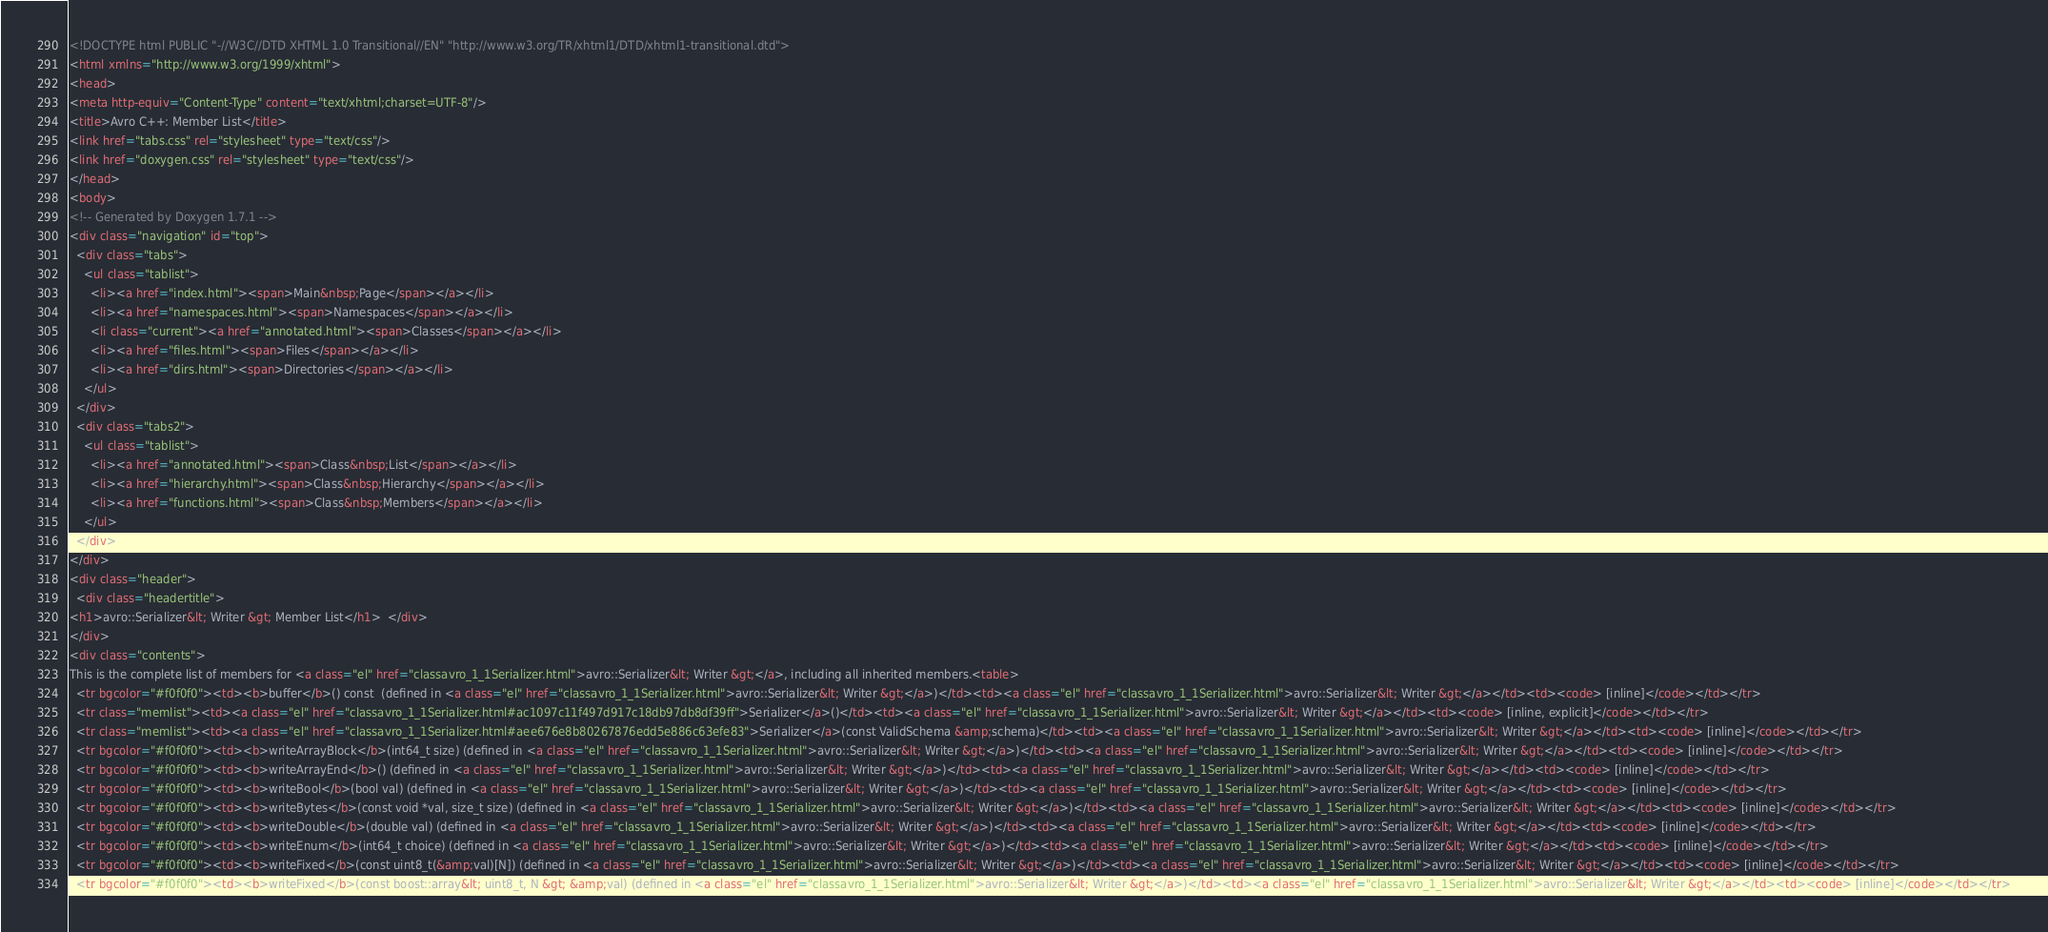Convert code to text. <code><loc_0><loc_0><loc_500><loc_500><_HTML_><!DOCTYPE html PUBLIC "-//W3C//DTD XHTML 1.0 Transitional//EN" "http://www.w3.org/TR/xhtml1/DTD/xhtml1-transitional.dtd">
<html xmlns="http://www.w3.org/1999/xhtml">
<head>
<meta http-equiv="Content-Type" content="text/xhtml;charset=UTF-8"/>
<title>Avro C++: Member List</title>
<link href="tabs.css" rel="stylesheet" type="text/css"/>
<link href="doxygen.css" rel="stylesheet" type="text/css"/>
</head>
<body>
<!-- Generated by Doxygen 1.7.1 -->
<div class="navigation" id="top">
  <div class="tabs">
    <ul class="tablist">
      <li><a href="index.html"><span>Main&nbsp;Page</span></a></li>
      <li><a href="namespaces.html"><span>Namespaces</span></a></li>
      <li class="current"><a href="annotated.html"><span>Classes</span></a></li>
      <li><a href="files.html"><span>Files</span></a></li>
      <li><a href="dirs.html"><span>Directories</span></a></li>
    </ul>
  </div>
  <div class="tabs2">
    <ul class="tablist">
      <li><a href="annotated.html"><span>Class&nbsp;List</span></a></li>
      <li><a href="hierarchy.html"><span>Class&nbsp;Hierarchy</span></a></li>
      <li><a href="functions.html"><span>Class&nbsp;Members</span></a></li>
    </ul>
  </div>
</div>
<div class="header">
  <div class="headertitle">
<h1>avro::Serializer&lt; Writer &gt; Member List</h1>  </div>
</div>
<div class="contents">
This is the complete list of members for <a class="el" href="classavro_1_1Serializer.html">avro::Serializer&lt; Writer &gt;</a>, including all inherited members.<table>
  <tr bgcolor="#f0f0f0"><td><b>buffer</b>() const  (defined in <a class="el" href="classavro_1_1Serializer.html">avro::Serializer&lt; Writer &gt;</a>)</td><td><a class="el" href="classavro_1_1Serializer.html">avro::Serializer&lt; Writer &gt;</a></td><td><code> [inline]</code></td></tr>
  <tr class="memlist"><td><a class="el" href="classavro_1_1Serializer.html#ac1097c11f497d917c18db97db8df39ff">Serializer</a>()</td><td><a class="el" href="classavro_1_1Serializer.html">avro::Serializer&lt; Writer &gt;</a></td><td><code> [inline, explicit]</code></td></tr>
  <tr class="memlist"><td><a class="el" href="classavro_1_1Serializer.html#aee676e8b80267876edd5e886c63efe83">Serializer</a>(const ValidSchema &amp;schema)</td><td><a class="el" href="classavro_1_1Serializer.html">avro::Serializer&lt; Writer &gt;</a></td><td><code> [inline]</code></td></tr>
  <tr bgcolor="#f0f0f0"><td><b>writeArrayBlock</b>(int64_t size) (defined in <a class="el" href="classavro_1_1Serializer.html">avro::Serializer&lt; Writer &gt;</a>)</td><td><a class="el" href="classavro_1_1Serializer.html">avro::Serializer&lt; Writer &gt;</a></td><td><code> [inline]</code></td></tr>
  <tr bgcolor="#f0f0f0"><td><b>writeArrayEnd</b>() (defined in <a class="el" href="classavro_1_1Serializer.html">avro::Serializer&lt; Writer &gt;</a>)</td><td><a class="el" href="classavro_1_1Serializer.html">avro::Serializer&lt; Writer &gt;</a></td><td><code> [inline]</code></td></tr>
  <tr bgcolor="#f0f0f0"><td><b>writeBool</b>(bool val) (defined in <a class="el" href="classavro_1_1Serializer.html">avro::Serializer&lt; Writer &gt;</a>)</td><td><a class="el" href="classavro_1_1Serializer.html">avro::Serializer&lt; Writer &gt;</a></td><td><code> [inline]</code></td></tr>
  <tr bgcolor="#f0f0f0"><td><b>writeBytes</b>(const void *val, size_t size) (defined in <a class="el" href="classavro_1_1Serializer.html">avro::Serializer&lt; Writer &gt;</a>)</td><td><a class="el" href="classavro_1_1Serializer.html">avro::Serializer&lt; Writer &gt;</a></td><td><code> [inline]</code></td></tr>
  <tr bgcolor="#f0f0f0"><td><b>writeDouble</b>(double val) (defined in <a class="el" href="classavro_1_1Serializer.html">avro::Serializer&lt; Writer &gt;</a>)</td><td><a class="el" href="classavro_1_1Serializer.html">avro::Serializer&lt; Writer &gt;</a></td><td><code> [inline]</code></td></tr>
  <tr bgcolor="#f0f0f0"><td><b>writeEnum</b>(int64_t choice) (defined in <a class="el" href="classavro_1_1Serializer.html">avro::Serializer&lt; Writer &gt;</a>)</td><td><a class="el" href="classavro_1_1Serializer.html">avro::Serializer&lt; Writer &gt;</a></td><td><code> [inline]</code></td></tr>
  <tr bgcolor="#f0f0f0"><td><b>writeFixed</b>(const uint8_t(&amp;val)[N]) (defined in <a class="el" href="classavro_1_1Serializer.html">avro::Serializer&lt; Writer &gt;</a>)</td><td><a class="el" href="classavro_1_1Serializer.html">avro::Serializer&lt; Writer &gt;</a></td><td><code> [inline]</code></td></tr>
  <tr bgcolor="#f0f0f0"><td><b>writeFixed</b>(const boost::array&lt; uint8_t, N &gt; &amp;val) (defined in <a class="el" href="classavro_1_1Serializer.html">avro::Serializer&lt; Writer &gt;</a>)</td><td><a class="el" href="classavro_1_1Serializer.html">avro::Serializer&lt; Writer &gt;</a></td><td><code> [inline]</code></td></tr></code> 